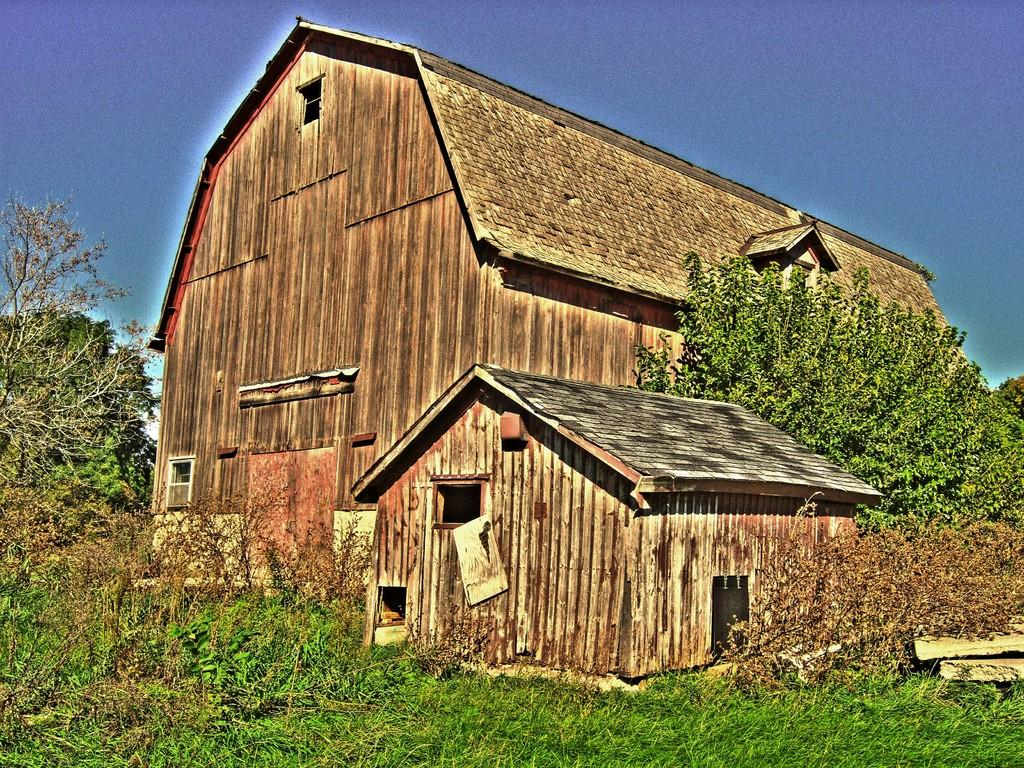What type of artwork is depicted in the image? The image is a painting. What structures can be seen in the painting? There are sheds in the painting. What type of vegetation is present in the painting? There are trees, logs, and plants in the painting. What part of the natural environment is visible in the painting? The sky is visible at the top of the painting. How many rabbits are hiding in the sheds in the painting? There are no rabbits present in the painting; it features sheds, trees, logs, and plants. What type of learning can be observed in the painting? There is no learning depicted in the painting; it is a scene of sheds, trees, logs, plants, and the sky. 